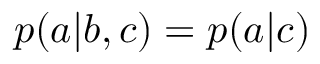Convert formula to latex. <formula><loc_0><loc_0><loc_500><loc_500>p ( a | b , c ) = p ( a | c )</formula> 